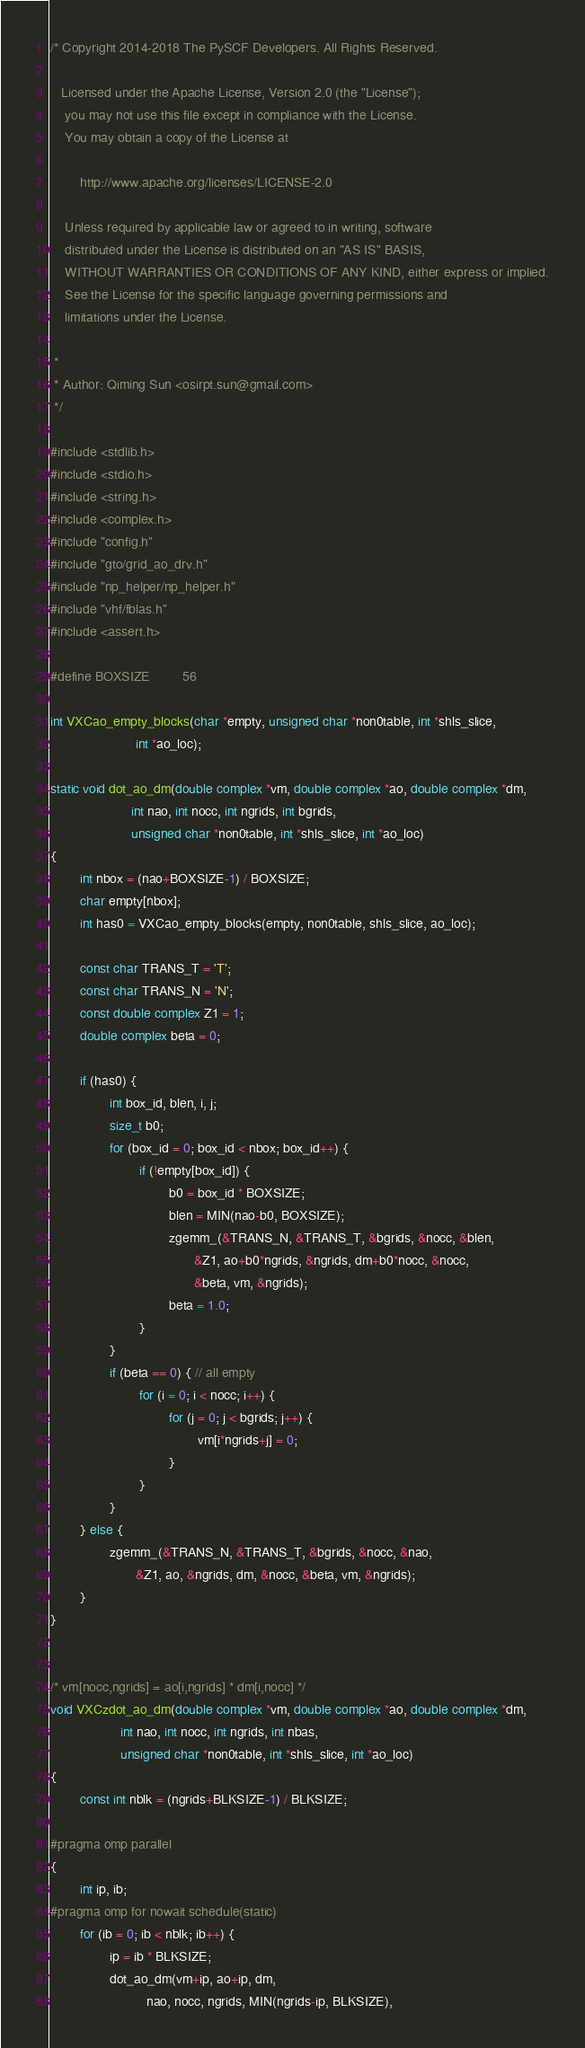Convert code to text. <code><loc_0><loc_0><loc_500><loc_500><_C_>/* Copyright 2014-2018 The PySCF Developers. All Rights Reserved.
  
   Licensed under the Apache License, Version 2.0 (the "License");
    you may not use this file except in compliance with the License.
    You may obtain a copy of the License at
 
        http://www.apache.org/licenses/LICENSE-2.0
 
    Unless required by applicable law or agreed to in writing, software
    distributed under the License is distributed on an "AS IS" BASIS,
    WITHOUT WARRANTIES OR CONDITIONS OF ANY KIND, either express or implied.
    See the License for the specific language governing permissions and
    limitations under the License.

 *
 * Author: Qiming Sun <osirpt.sun@gmail.com>
 */

#include <stdlib.h>
#include <stdio.h>
#include <string.h>
#include <complex.h>
#include "config.h"
#include "gto/grid_ao_drv.h"
#include "np_helper/np_helper.h"
#include "vhf/fblas.h"
#include <assert.h>

#define BOXSIZE         56

int VXCao_empty_blocks(char *empty, unsigned char *non0table, int *shls_slice,
                       int *ao_loc);

static void dot_ao_dm(double complex *vm, double complex *ao, double complex *dm,
                      int nao, int nocc, int ngrids, int bgrids,
                      unsigned char *non0table, int *shls_slice, int *ao_loc)
{
        int nbox = (nao+BOXSIZE-1) / BOXSIZE;
        char empty[nbox];
        int has0 = VXCao_empty_blocks(empty, non0table, shls_slice, ao_loc);

        const char TRANS_T = 'T';
        const char TRANS_N = 'N';
        const double complex Z1 = 1;
        double complex beta = 0;

        if (has0) {
                int box_id, blen, i, j;
                size_t b0;
                for (box_id = 0; box_id < nbox; box_id++) {
                        if (!empty[box_id]) {
                                b0 = box_id * BOXSIZE;
                                blen = MIN(nao-b0, BOXSIZE);
                                zgemm_(&TRANS_N, &TRANS_T, &bgrids, &nocc, &blen,
                                       &Z1, ao+b0*ngrids, &ngrids, dm+b0*nocc, &nocc,
                                       &beta, vm, &ngrids);
                                beta = 1.0;
                        }
                }
                if (beta == 0) { // all empty
                        for (i = 0; i < nocc; i++) {
                                for (j = 0; j < bgrids; j++) {
                                        vm[i*ngrids+j] = 0;
                                }
                        }
                }
        } else {
                zgemm_(&TRANS_N, &TRANS_T, &bgrids, &nocc, &nao,
                       &Z1, ao, &ngrids, dm, &nocc, &beta, vm, &ngrids);
        }
}


/* vm[nocc,ngrids] = ao[i,ngrids] * dm[i,nocc] */
void VXCzdot_ao_dm(double complex *vm, double complex *ao, double complex *dm,
                   int nao, int nocc, int ngrids, int nbas,
                   unsigned char *non0table, int *shls_slice, int *ao_loc)
{
        const int nblk = (ngrids+BLKSIZE-1) / BLKSIZE;

#pragma omp parallel
{
        int ip, ib;
#pragma omp for nowait schedule(static)
        for (ib = 0; ib < nblk; ib++) {
                ip = ib * BLKSIZE;
                dot_ao_dm(vm+ip, ao+ip, dm,
                          nao, nocc, ngrids, MIN(ngrids-ip, BLKSIZE),</code> 